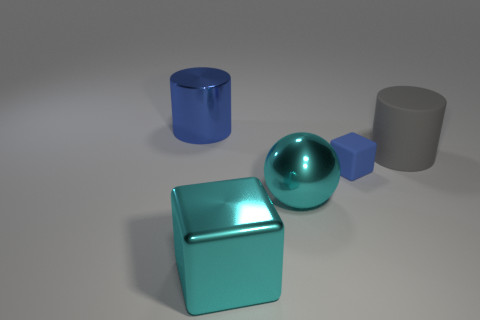Subtract all gray cylinders. How many cylinders are left? 1 Add 3 big cylinders. How many objects exist? 8 Subtract all cubes. How many objects are left? 3 Subtract 1 blocks. How many blocks are left? 1 Subtract all cyan cylinders. Subtract all cyan balls. How many cylinders are left? 2 Subtract all blue cubes. How many red spheres are left? 0 Subtract all spheres. Subtract all shiny objects. How many objects are left? 1 Add 2 matte objects. How many matte objects are left? 4 Add 3 tiny matte things. How many tiny matte things exist? 4 Subtract 0 brown cylinders. How many objects are left? 5 